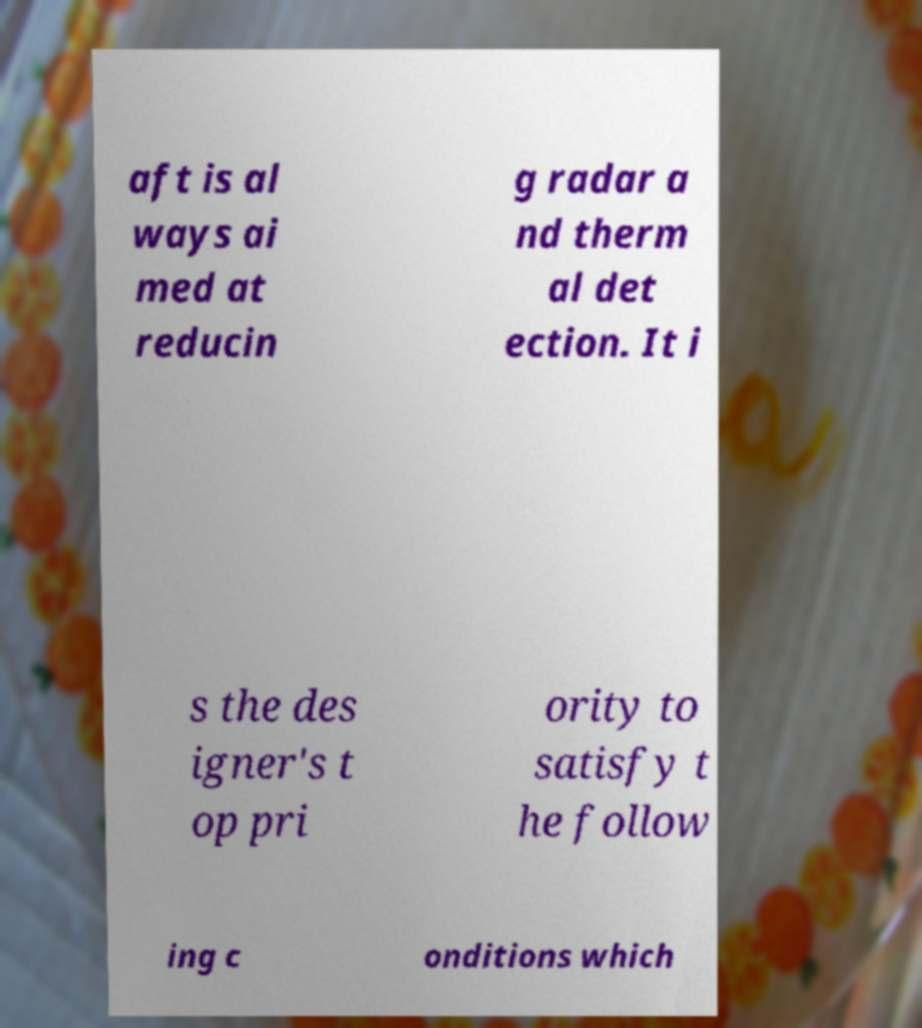There's text embedded in this image that I need extracted. Can you transcribe it verbatim? aft is al ways ai med at reducin g radar a nd therm al det ection. It i s the des igner's t op pri ority to satisfy t he follow ing c onditions which 